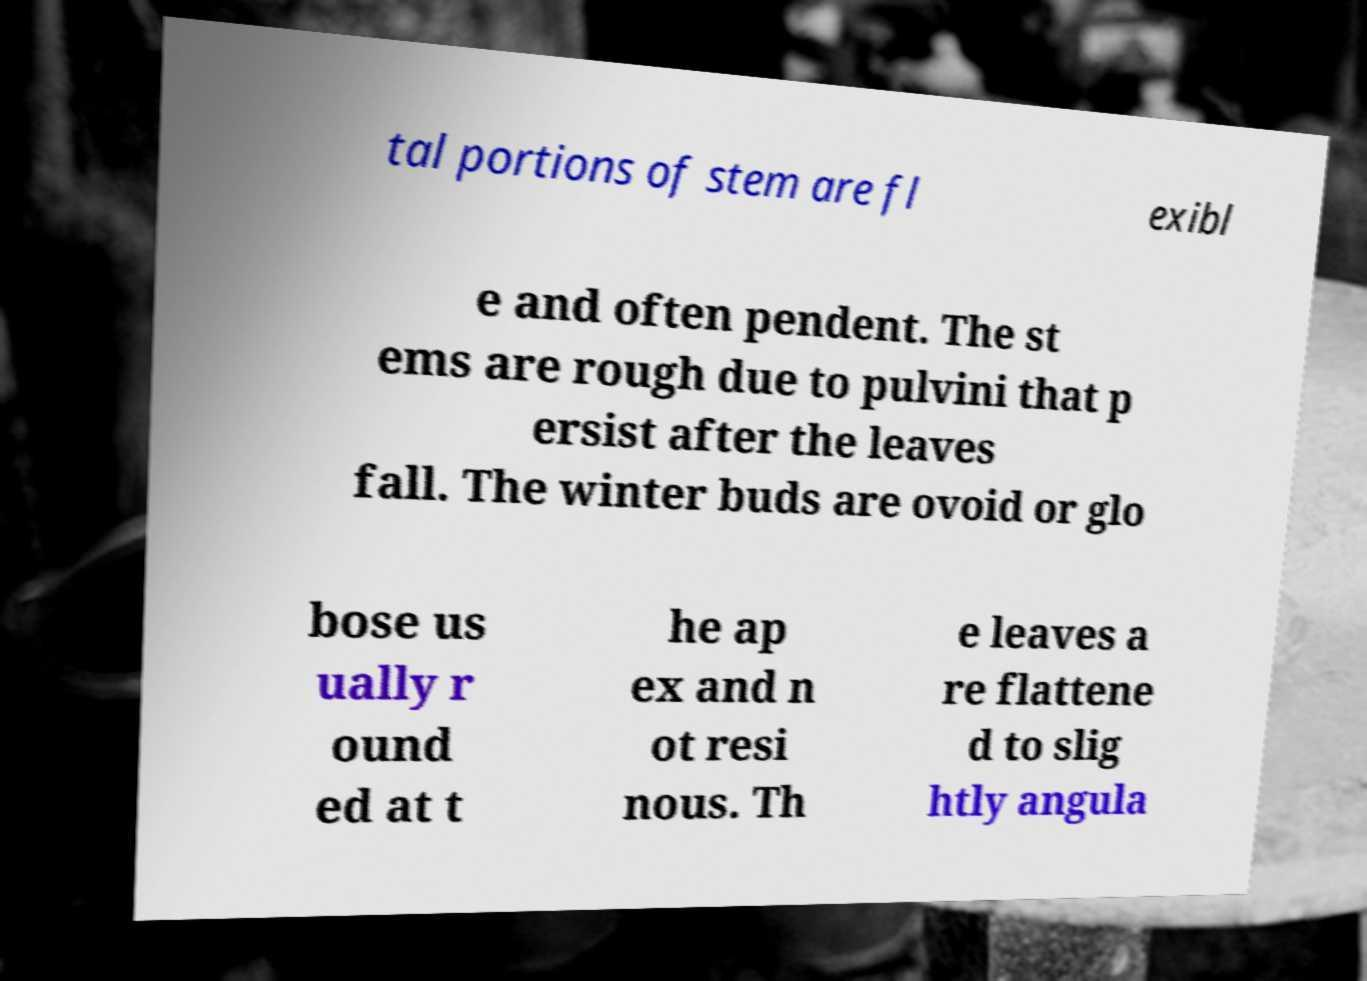I need the written content from this picture converted into text. Can you do that? tal portions of stem are fl exibl e and often pendent. The st ems are rough due to pulvini that p ersist after the leaves fall. The winter buds are ovoid or glo bose us ually r ound ed at t he ap ex and n ot resi nous. Th e leaves a re flattene d to slig htly angula 